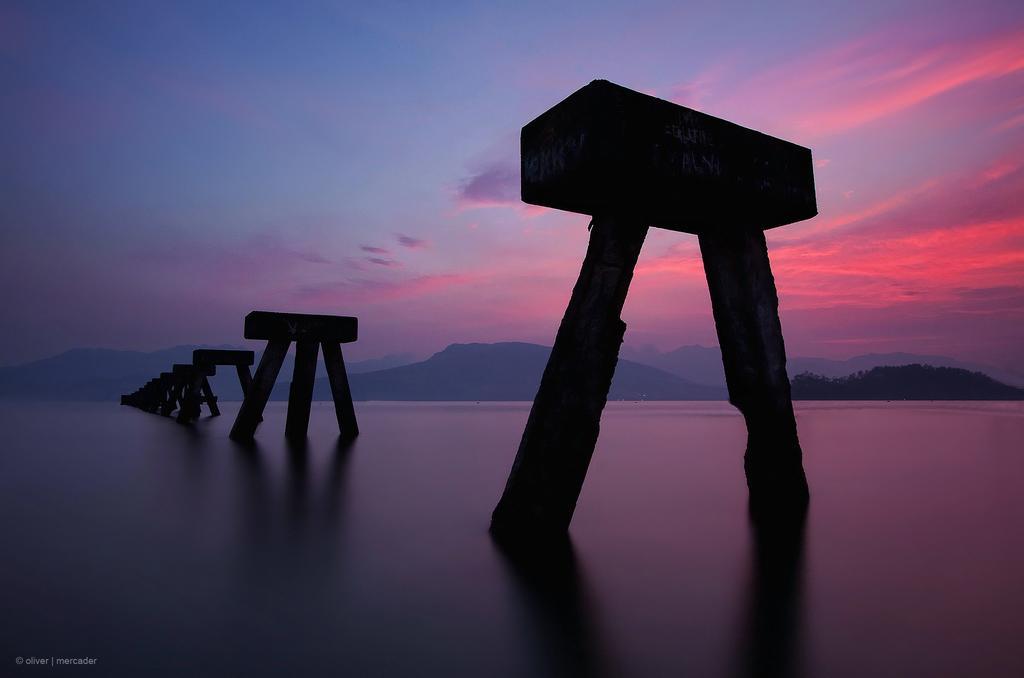Could you give a brief overview of what you see in this image? In this image at the bottom there is a river, and in that river there are some walls and in the background there are some mountains and trees. At the top of the image there is sky. 